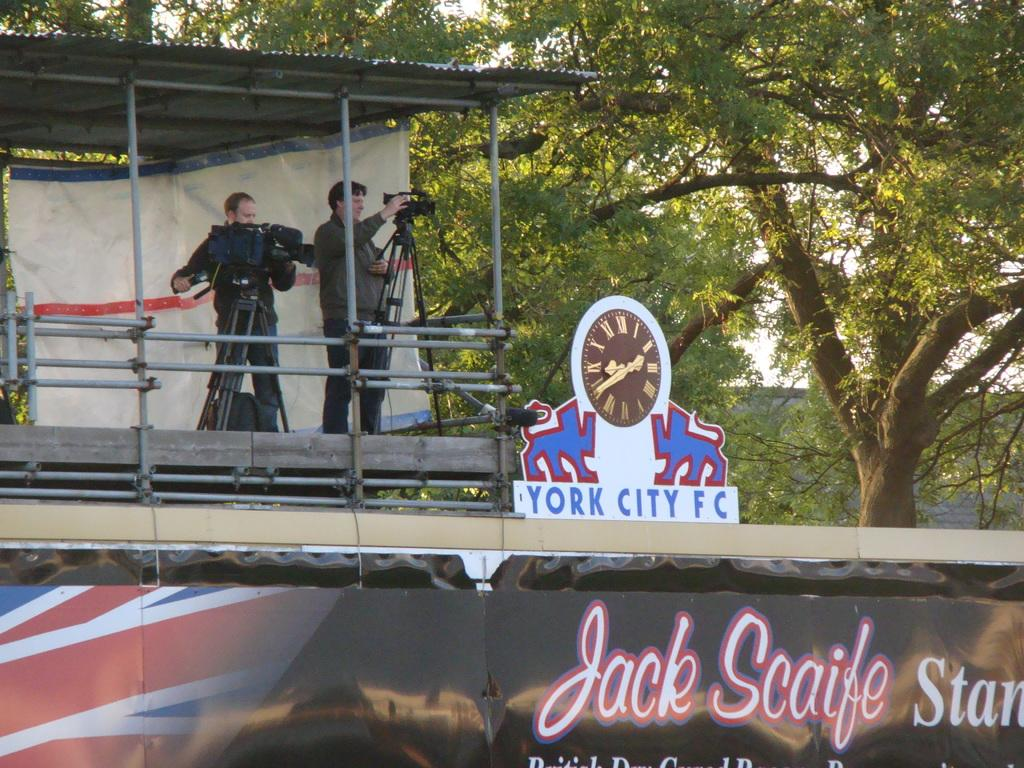<image>
Present a compact description of the photo's key features. People standing behind a sign which says YORK CITY FC. 